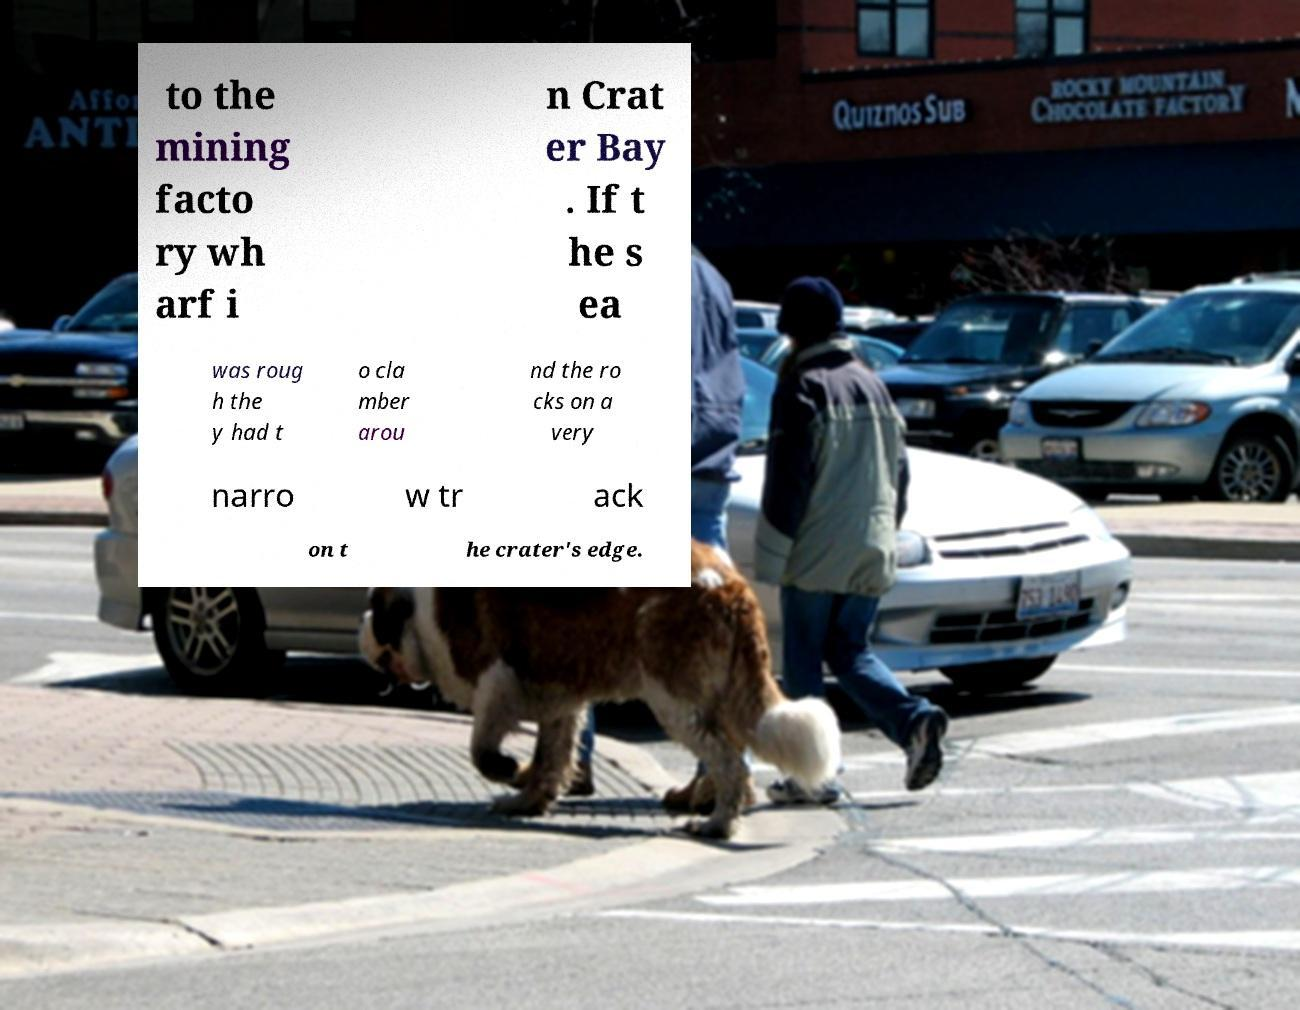For documentation purposes, I need the text within this image transcribed. Could you provide that? to the mining facto ry wh arf i n Crat er Bay . If t he s ea was roug h the y had t o cla mber arou nd the ro cks on a very narro w tr ack on t he crater's edge. 